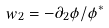<formula> <loc_0><loc_0><loc_500><loc_500>w _ { 2 } = - \partial _ { 2 } \phi / \phi ^ { \ast }</formula> 